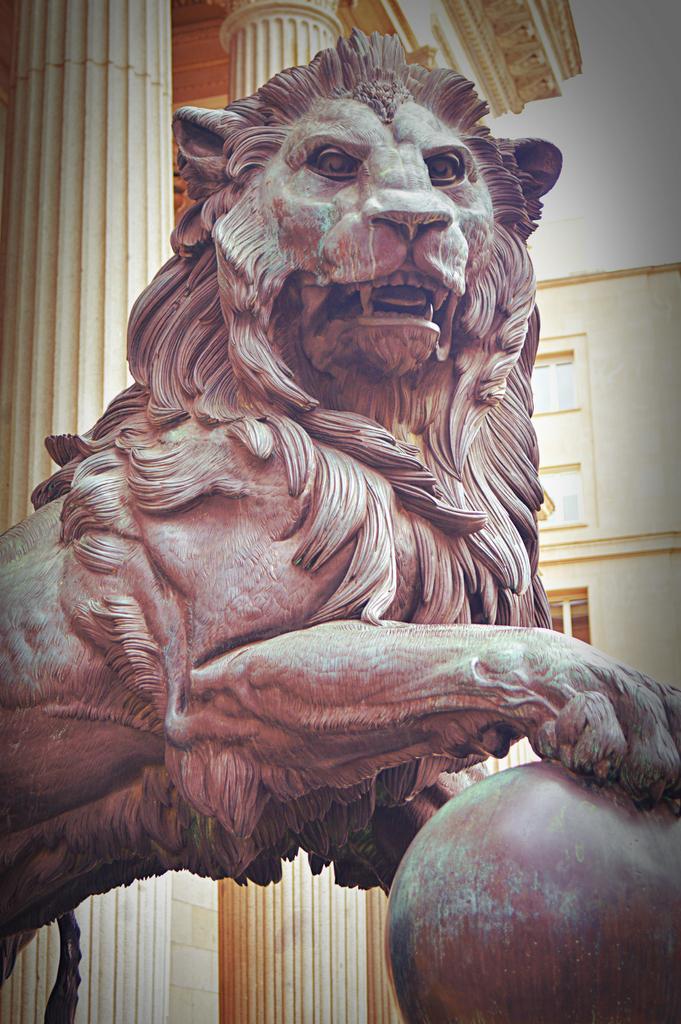Describe this image in one or two sentences. In this image, I can see the sculpture of a lion. In the background, that looks like a building with the pillars and windows. 